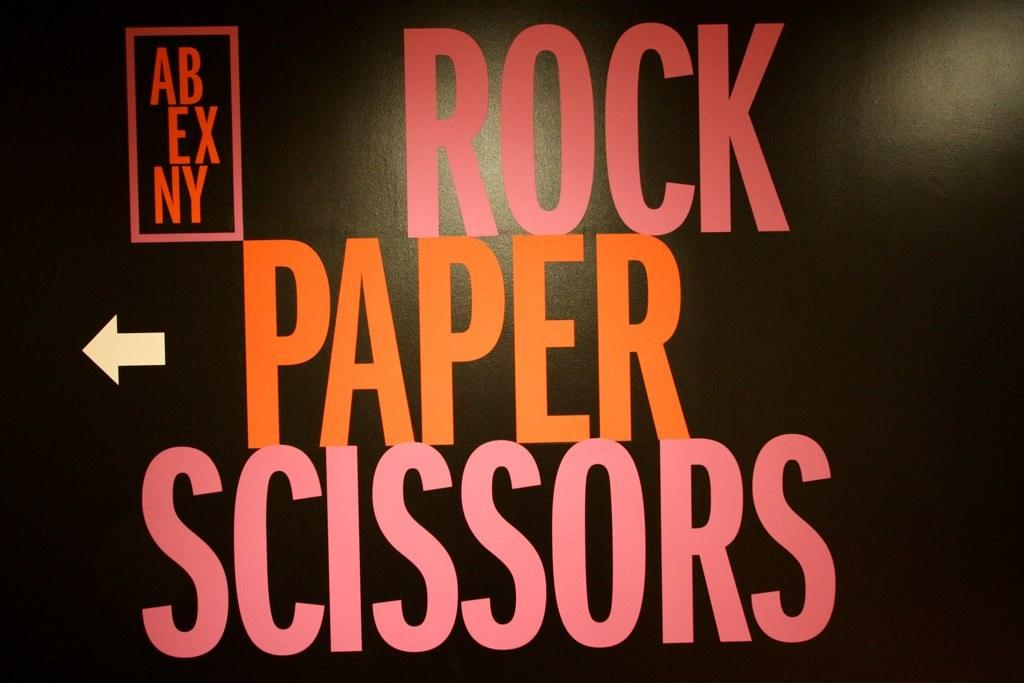<image>
Render a clear and concise summary of the photo. A black sign with words about rock paper scissors written on it. 